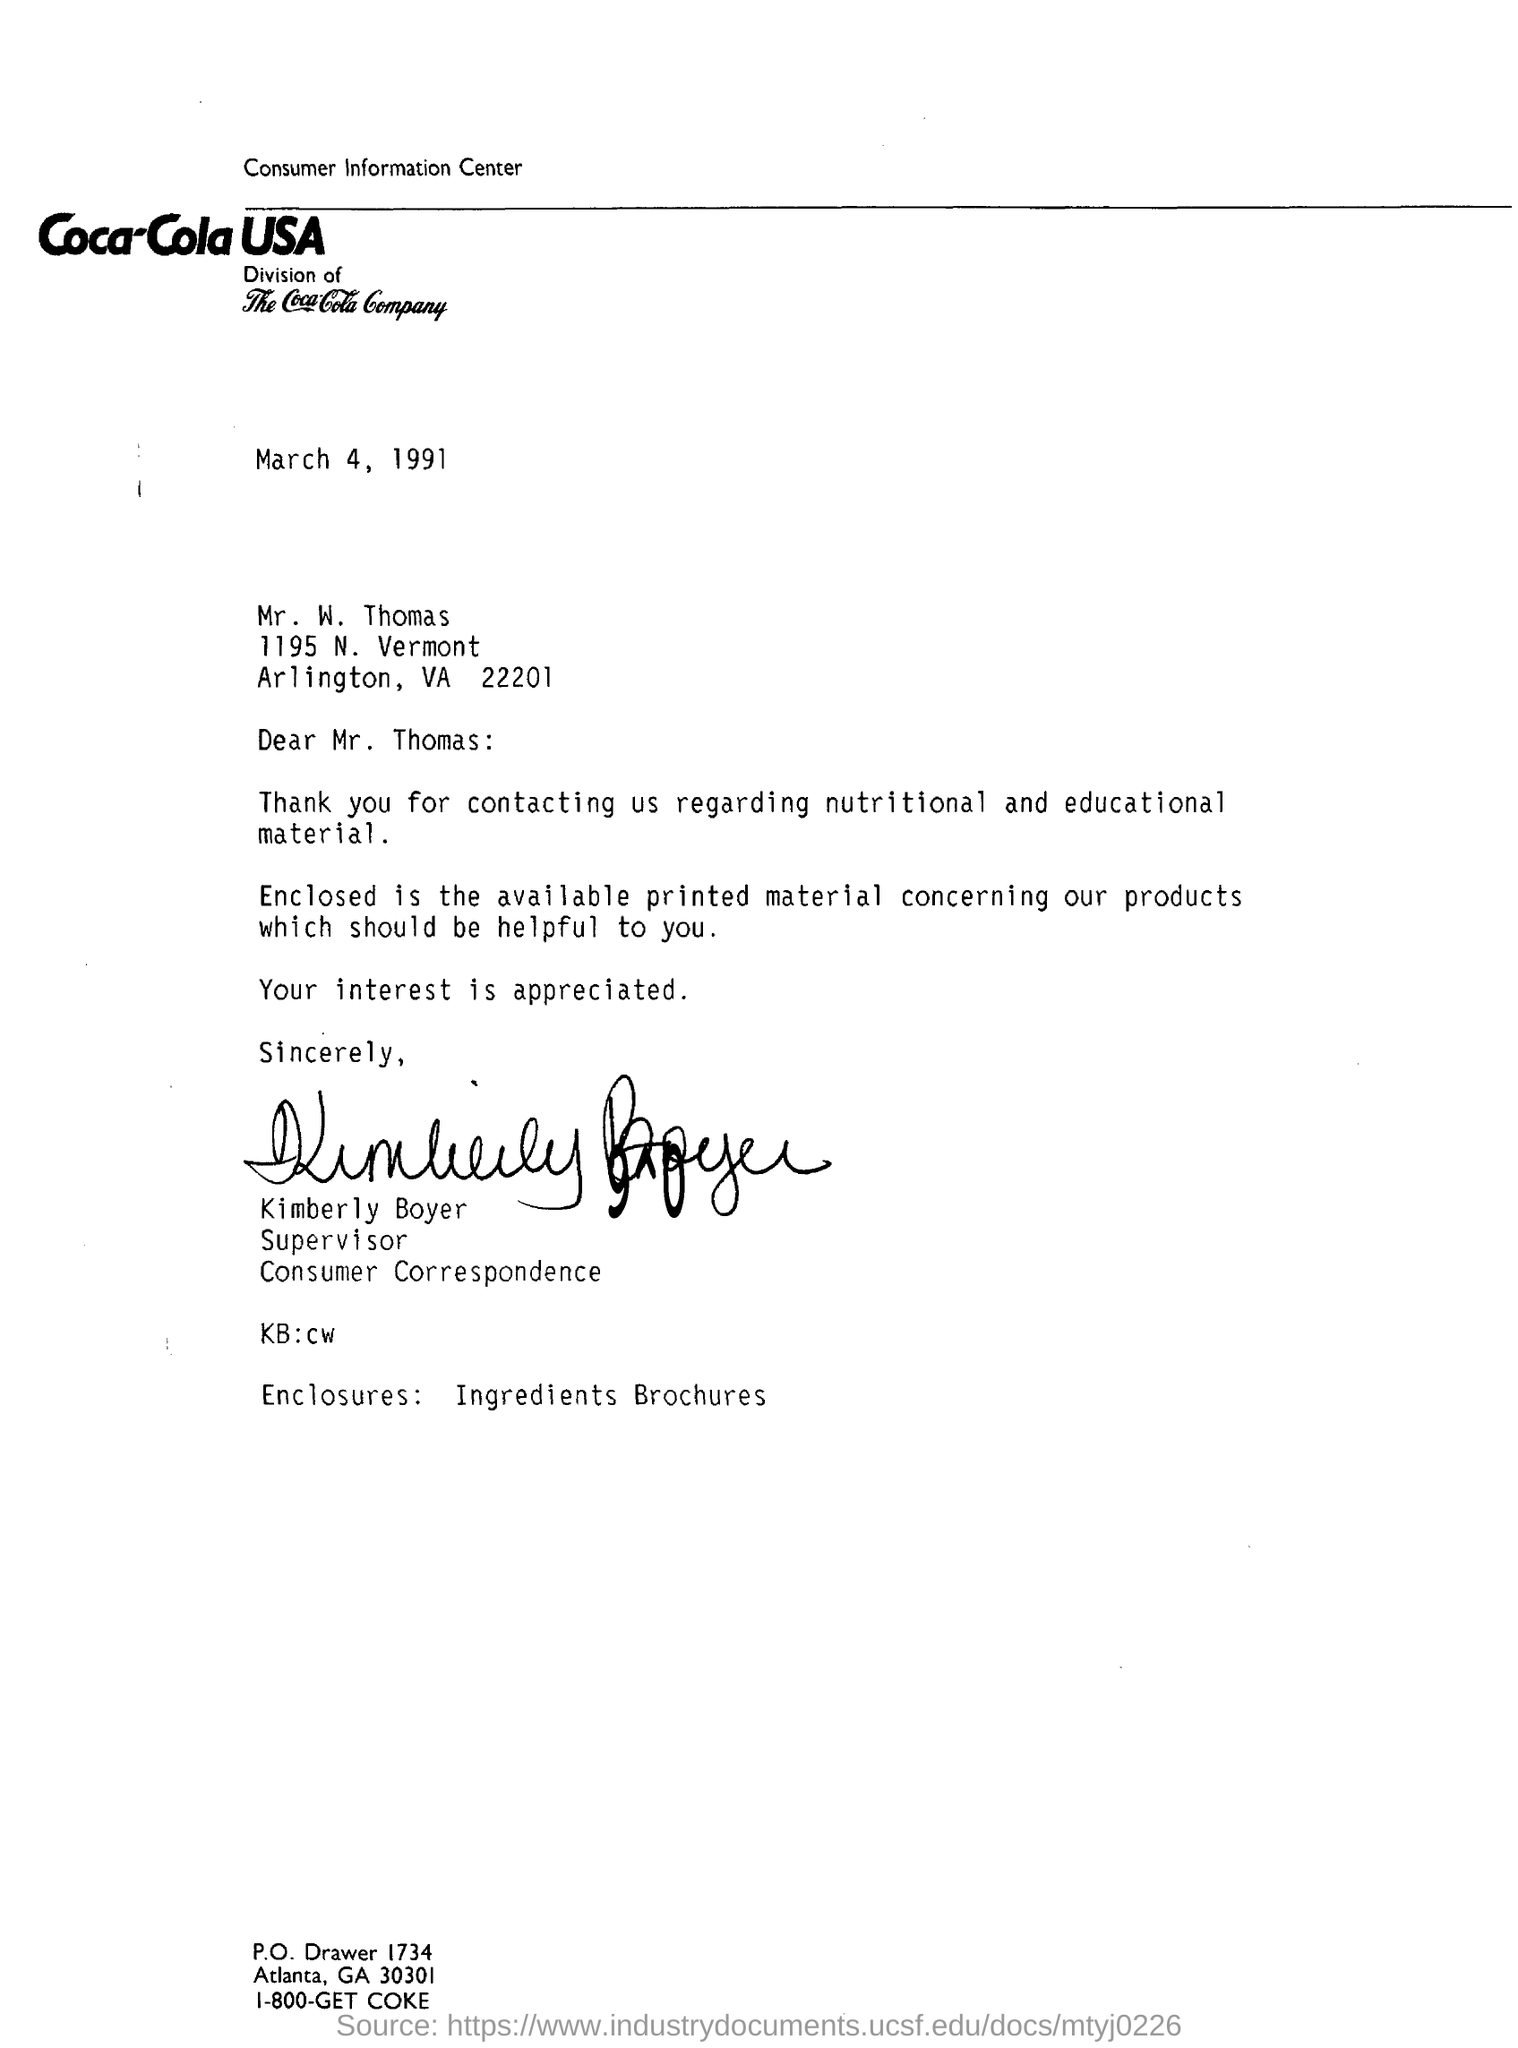To whom, the letter is addressed?
Keep it short and to the point. Mr. W. Thomas. Who is the consumer correspondence of coca cola USA?
Your answer should be compact. Kimberly boyer. What is the date mentioned in the letter?
Ensure brevity in your answer.  March 4, 1991. 